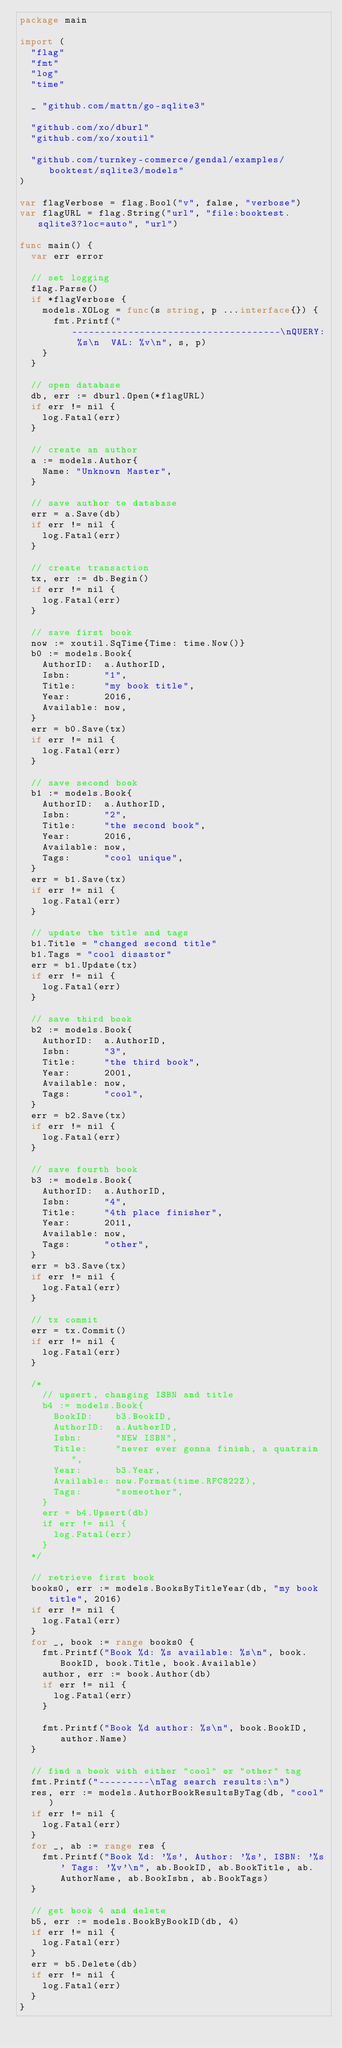Convert code to text. <code><loc_0><loc_0><loc_500><loc_500><_Go_>package main

import (
	"flag"
	"fmt"
	"log"
	"time"

	_ "github.com/mattn/go-sqlite3"

	"github.com/xo/dburl"
	"github.com/xo/xoutil"

	"github.com/turnkey-commerce/gendal/examples/booktest/sqlite3/models"
)

var flagVerbose = flag.Bool("v", false, "verbose")
var flagURL = flag.String("url", "file:booktest.sqlite3?loc=auto", "url")

func main() {
	var err error

	// set logging
	flag.Parse()
	if *flagVerbose {
		models.XOLog = func(s string, p ...interface{}) {
			fmt.Printf("-------------------------------------\nQUERY: %s\n  VAL: %v\n", s, p)
		}
	}

	// open database
	db, err := dburl.Open(*flagURL)
	if err != nil {
		log.Fatal(err)
	}

	// create an author
	a := models.Author{
		Name: "Unknown Master",
	}

	// save author to database
	err = a.Save(db)
	if err != nil {
		log.Fatal(err)
	}

	// create transaction
	tx, err := db.Begin()
	if err != nil {
		log.Fatal(err)
	}

	// save first book
	now := xoutil.SqTime{Time: time.Now()}
	b0 := models.Book{
		AuthorID:  a.AuthorID,
		Isbn:      "1",
		Title:     "my book title",
		Year:      2016,
		Available: now,
	}
	err = b0.Save(tx)
	if err != nil {
		log.Fatal(err)
	}

	// save second book
	b1 := models.Book{
		AuthorID:  a.AuthorID,
		Isbn:      "2",
		Title:     "the second book",
		Year:      2016,
		Available: now,
		Tags:      "cool unique",
	}
	err = b1.Save(tx)
	if err != nil {
		log.Fatal(err)
	}

	// update the title and tags
	b1.Title = "changed second title"
	b1.Tags = "cool disastor"
	err = b1.Update(tx)
	if err != nil {
		log.Fatal(err)
	}

	// save third book
	b2 := models.Book{
		AuthorID:  a.AuthorID,
		Isbn:      "3",
		Title:     "the third book",
		Year:      2001,
		Available: now,
		Tags:      "cool",
	}
	err = b2.Save(tx)
	if err != nil {
		log.Fatal(err)
	}

	// save fourth book
	b3 := models.Book{
		AuthorID:  a.AuthorID,
		Isbn:      "4",
		Title:     "4th place finisher",
		Year:      2011,
		Available: now,
		Tags:      "other",
	}
	err = b3.Save(tx)
	if err != nil {
		log.Fatal(err)
	}

	// tx commit
	err = tx.Commit()
	if err != nil {
		log.Fatal(err)
	}

	/*
		// upsert, changing ISBN and title
		b4 := models.Book{
			BookID:    b3.BookID,
			AuthorID:  a.AuthorID,
			Isbn:      "NEW ISBN",
			Title:     "never ever gonna finish, a quatrain",
			Year:      b3.Year,
			Available: now.Format(time.RFC822Z),
			Tags:      "someother",
		}
		err = b4.Upsert(db)
		if err != nil {
			log.Fatal(err)
		}
	*/

	// retrieve first book
	books0, err := models.BooksByTitleYear(db, "my book title", 2016)
	if err != nil {
		log.Fatal(err)
	}
	for _, book := range books0 {
		fmt.Printf("Book %d: %s available: %s\n", book.BookID, book.Title, book.Available)
		author, err := book.Author(db)
		if err != nil {
			log.Fatal(err)
		}

		fmt.Printf("Book %d author: %s\n", book.BookID, author.Name)
	}

	// find a book with either "cool" or "other" tag
	fmt.Printf("---------\nTag search results:\n")
	res, err := models.AuthorBookResultsByTag(db, "cool")
	if err != nil {
		log.Fatal(err)
	}
	for _, ab := range res {
		fmt.Printf("Book %d: '%s', Author: '%s', ISBN: '%s' Tags: '%v'\n", ab.BookID, ab.BookTitle, ab.AuthorName, ab.BookIsbn, ab.BookTags)
	}

	// get book 4 and delete
	b5, err := models.BookByBookID(db, 4)
	if err != nil {
		log.Fatal(err)
	}
	err = b5.Delete(db)
	if err != nil {
		log.Fatal(err)
	}
}
</code> 